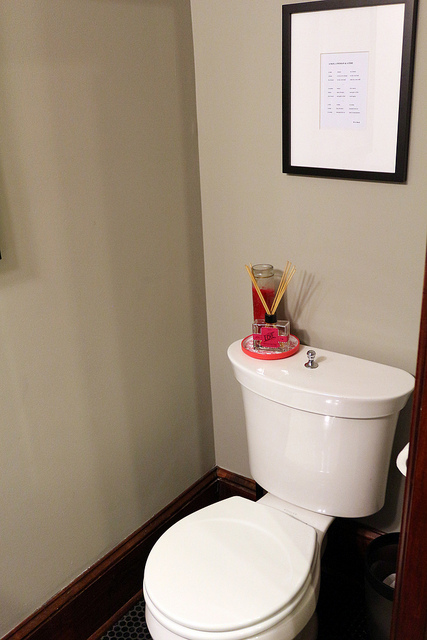How many toilets are there? There is one toilet visible in the image, situated against a wall with a framed document or picture hanging above it. 